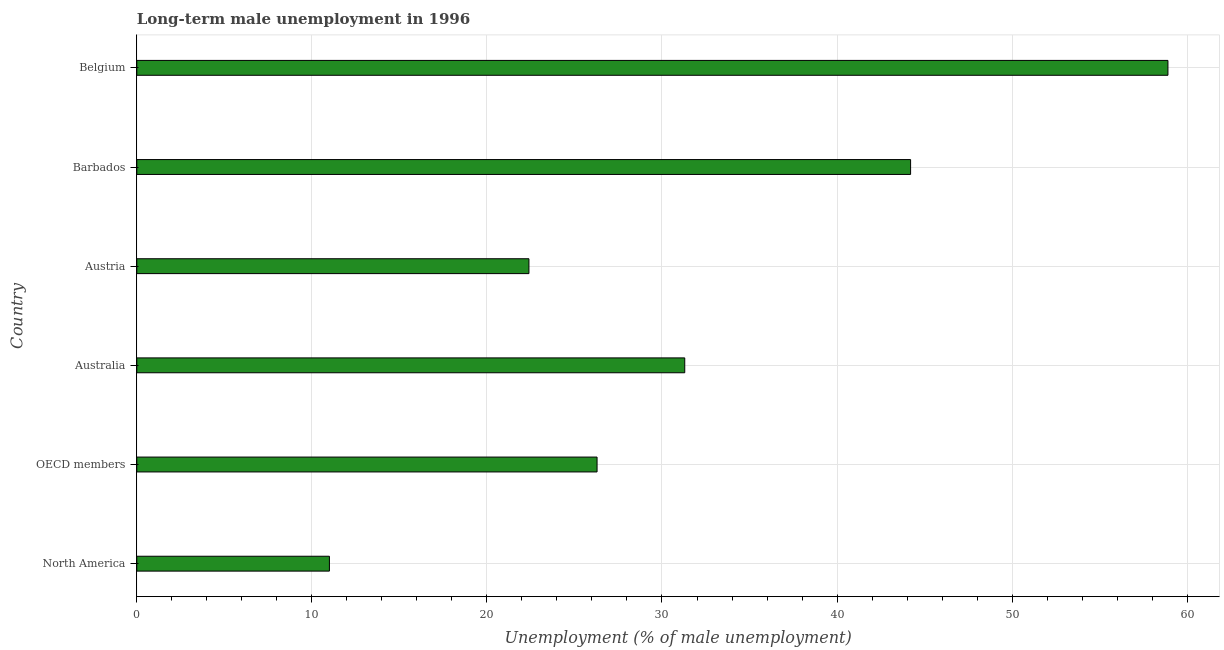Does the graph contain any zero values?
Offer a very short reply. No. Does the graph contain grids?
Offer a terse response. Yes. What is the title of the graph?
Provide a short and direct response. Long-term male unemployment in 1996. What is the label or title of the X-axis?
Your response must be concise. Unemployment (% of male unemployment). What is the label or title of the Y-axis?
Make the answer very short. Country. What is the long-term male unemployment in Barbados?
Give a very brief answer. 44.2. Across all countries, what is the maximum long-term male unemployment?
Ensure brevity in your answer.  58.9. Across all countries, what is the minimum long-term male unemployment?
Offer a terse response. 11. What is the sum of the long-term male unemployment?
Ensure brevity in your answer.  194.09. What is the difference between the long-term male unemployment in Belgium and OECD members?
Ensure brevity in your answer.  32.61. What is the average long-term male unemployment per country?
Make the answer very short. 32.35. What is the median long-term male unemployment?
Make the answer very short. 28.8. In how many countries, is the long-term male unemployment greater than 52 %?
Offer a very short reply. 1. What is the ratio of the long-term male unemployment in North America to that in OECD members?
Provide a short and direct response. 0.42. Is the long-term male unemployment in Belgium less than that in OECD members?
Offer a terse response. No. Is the difference between the long-term male unemployment in Austria and North America greater than the difference between any two countries?
Your answer should be compact. No. What is the difference between the highest and the second highest long-term male unemployment?
Keep it short and to the point. 14.7. What is the difference between the highest and the lowest long-term male unemployment?
Give a very brief answer. 47.9. In how many countries, is the long-term male unemployment greater than the average long-term male unemployment taken over all countries?
Make the answer very short. 2. How many bars are there?
Ensure brevity in your answer.  6. How many countries are there in the graph?
Provide a succinct answer. 6. What is the difference between two consecutive major ticks on the X-axis?
Offer a very short reply. 10. Are the values on the major ticks of X-axis written in scientific E-notation?
Provide a succinct answer. No. What is the Unemployment (% of male unemployment) in North America?
Your answer should be very brief. 11. What is the Unemployment (% of male unemployment) in OECD members?
Ensure brevity in your answer.  26.29. What is the Unemployment (% of male unemployment) in Australia?
Offer a terse response. 31.3. What is the Unemployment (% of male unemployment) in Austria?
Give a very brief answer. 22.4. What is the Unemployment (% of male unemployment) of Barbados?
Offer a very short reply. 44.2. What is the Unemployment (% of male unemployment) in Belgium?
Give a very brief answer. 58.9. What is the difference between the Unemployment (% of male unemployment) in North America and OECD members?
Your answer should be compact. -15.29. What is the difference between the Unemployment (% of male unemployment) in North America and Australia?
Your answer should be very brief. -20.3. What is the difference between the Unemployment (% of male unemployment) in North America and Austria?
Keep it short and to the point. -11.4. What is the difference between the Unemployment (% of male unemployment) in North America and Barbados?
Your answer should be compact. -33.2. What is the difference between the Unemployment (% of male unemployment) in North America and Belgium?
Give a very brief answer. -47.9. What is the difference between the Unemployment (% of male unemployment) in OECD members and Australia?
Make the answer very short. -5.01. What is the difference between the Unemployment (% of male unemployment) in OECD members and Austria?
Provide a succinct answer. 3.89. What is the difference between the Unemployment (% of male unemployment) in OECD members and Barbados?
Ensure brevity in your answer.  -17.91. What is the difference between the Unemployment (% of male unemployment) in OECD members and Belgium?
Ensure brevity in your answer.  -32.61. What is the difference between the Unemployment (% of male unemployment) in Australia and Barbados?
Ensure brevity in your answer.  -12.9. What is the difference between the Unemployment (% of male unemployment) in Australia and Belgium?
Your answer should be compact. -27.6. What is the difference between the Unemployment (% of male unemployment) in Austria and Barbados?
Keep it short and to the point. -21.8. What is the difference between the Unemployment (% of male unemployment) in Austria and Belgium?
Provide a succinct answer. -36.5. What is the difference between the Unemployment (% of male unemployment) in Barbados and Belgium?
Ensure brevity in your answer.  -14.7. What is the ratio of the Unemployment (% of male unemployment) in North America to that in OECD members?
Your response must be concise. 0.42. What is the ratio of the Unemployment (% of male unemployment) in North America to that in Australia?
Offer a terse response. 0.35. What is the ratio of the Unemployment (% of male unemployment) in North America to that in Austria?
Ensure brevity in your answer.  0.49. What is the ratio of the Unemployment (% of male unemployment) in North America to that in Barbados?
Offer a very short reply. 0.25. What is the ratio of the Unemployment (% of male unemployment) in North America to that in Belgium?
Offer a very short reply. 0.19. What is the ratio of the Unemployment (% of male unemployment) in OECD members to that in Australia?
Give a very brief answer. 0.84. What is the ratio of the Unemployment (% of male unemployment) in OECD members to that in Austria?
Give a very brief answer. 1.17. What is the ratio of the Unemployment (% of male unemployment) in OECD members to that in Barbados?
Your response must be concise. 0.59. What is the ratio of the Unemployment (% of male unemployment) in OECD members to that in Belgium?
Make the answer very short. 0.45. What is the ratio of the Unemployment (% of male unemployment) in Australia to that in Austria?
Provide a short and direct response. 1.4. What is the ratio of the Unemployment (% of male unemployment) in Australia to that in Barbados?
Make the answer very short. 0.71. What is the ratio of the Unemployment (% of male unemployment) in Australia to that in Belgium?
Your response must be concise. 0.53. What is the ratio of the Unemployment (% of male unemployment) in Austria to that in Barbados?
Provide a short and direct response. 0.51. What is the ratio of the Unemployment (% of male unemployment) in Austria to that in Belgium?
Provide a succinct answer. 0.38. 